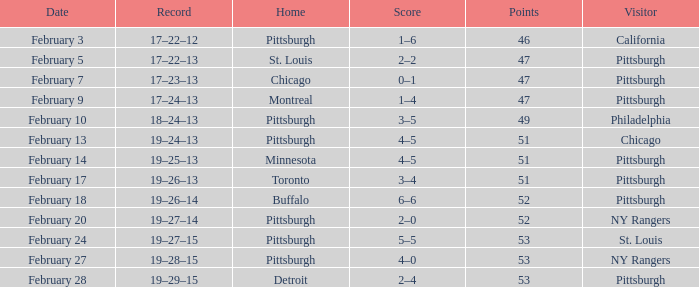Which Score has a Date of february 9? 1–4. 